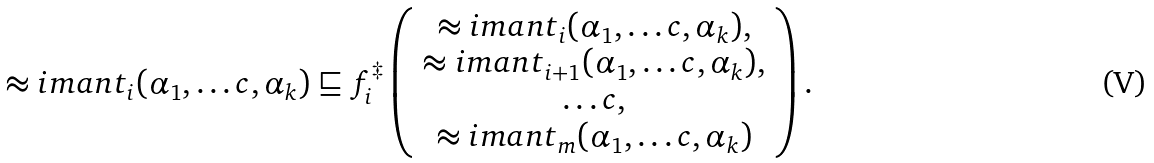<formula> <loc_0><loc_0><loc_500><loc_500>\approx i m a n t _ { i } ( \alpha _ { 1 } , \dots c , \alpha _ { k } ) \sqsubseteq f ^ { \ddagger } _ { i } \left ( \begin{array} { c } \approx i m a n t _ { i } ( \alpha _ { 1 } , \dots c , \alpha _ { k } ) , \\ \approx i m a n t _ { i + 1 } ( \alpha _ { 1 } , \dots c , \alpha _ { k } ) , \\ \dots c , \\ \approx i m a n t _ { m } ( \alpha _ { 1 } , \dots c , \alpha _ { k } ) \end{array} \right ) .</formula> 